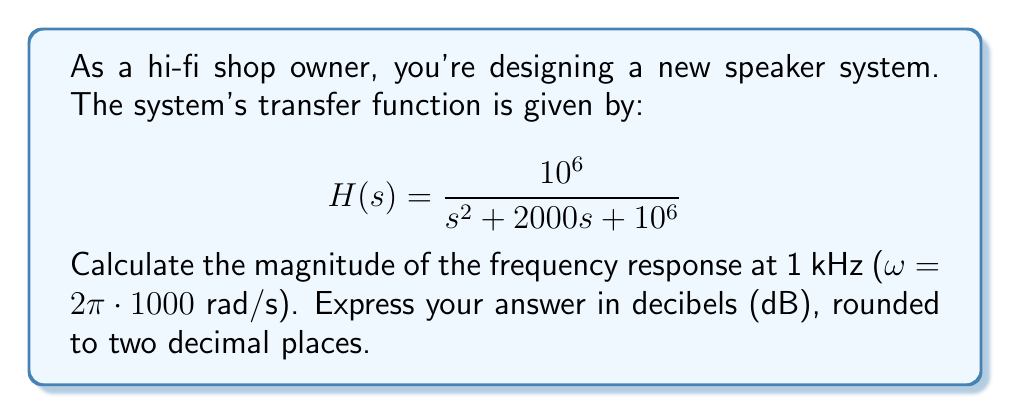Can you answer this question? To solve this problem, we'll follow these steps:

1) Replace s with jω in the transfer function:
   $$H(j\omega) = \frac{10^6}{(j\omega)^2 + 2000(j\omega) + 10^6}$$

2) Substitute ω = 2π * 1000 = 6283.19 rad/s:
   $$H(j6283.19) = \frac{10^6}{(j6283.19)^2 + 2000(j6283.19) + 10^6}$$

3) Simplify the denominator:
   $$H(j6283.19) = \frac{10^6}{-39478476.5 + j12566380 + 10^6}$$
   $$H(j6283.19) = \frac{10^6}{-38478476.5 + j12566380}$$

4) Calculate the magnitude of the complex number in the denominator:
   $$|denominator| = \sqrt{(-38478476.5)^2 + (12566380)^2} = 40477612.7$$

5) The magnitude of the frequency response is:
   $$|H(j6283.19)| = \frac{10^6}{40477612.7} = 0.0247$$

6) Convert to decibels:
   $$20 \log_{10}(0.0247) = -32.14 \text{ dB}$$
Answer: -32.14 dB 